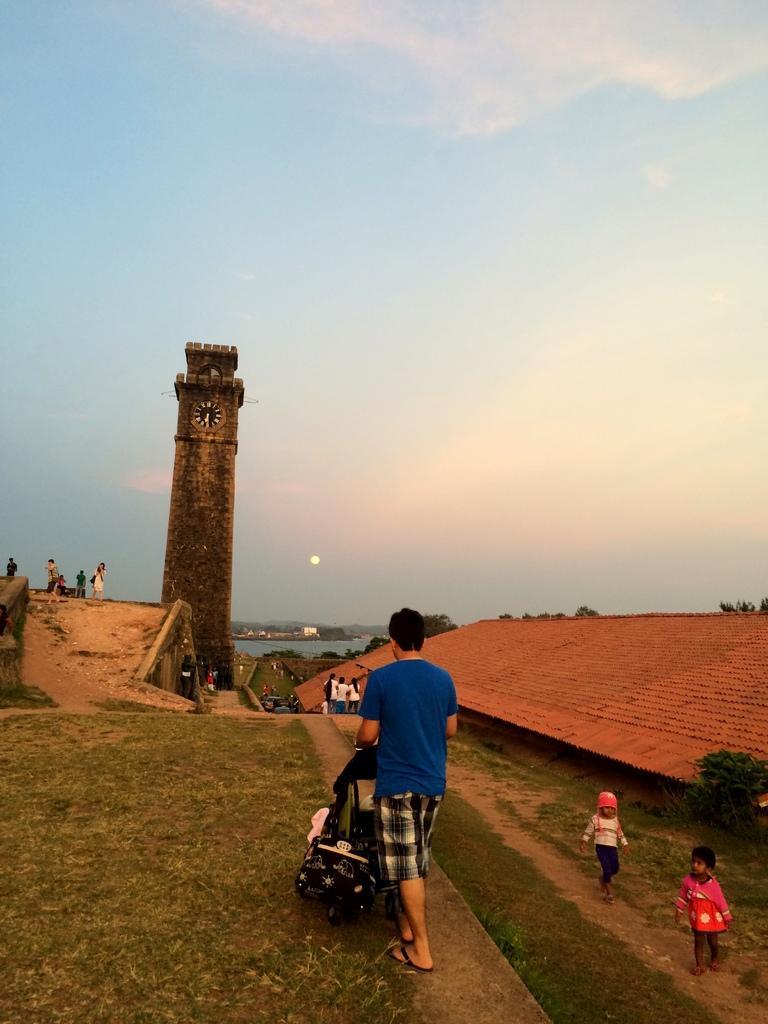How would you summarize this image in a sentence or two? In this picture there are few persons standing and there is a clock tower in front of them and there are trees and water in the background. 